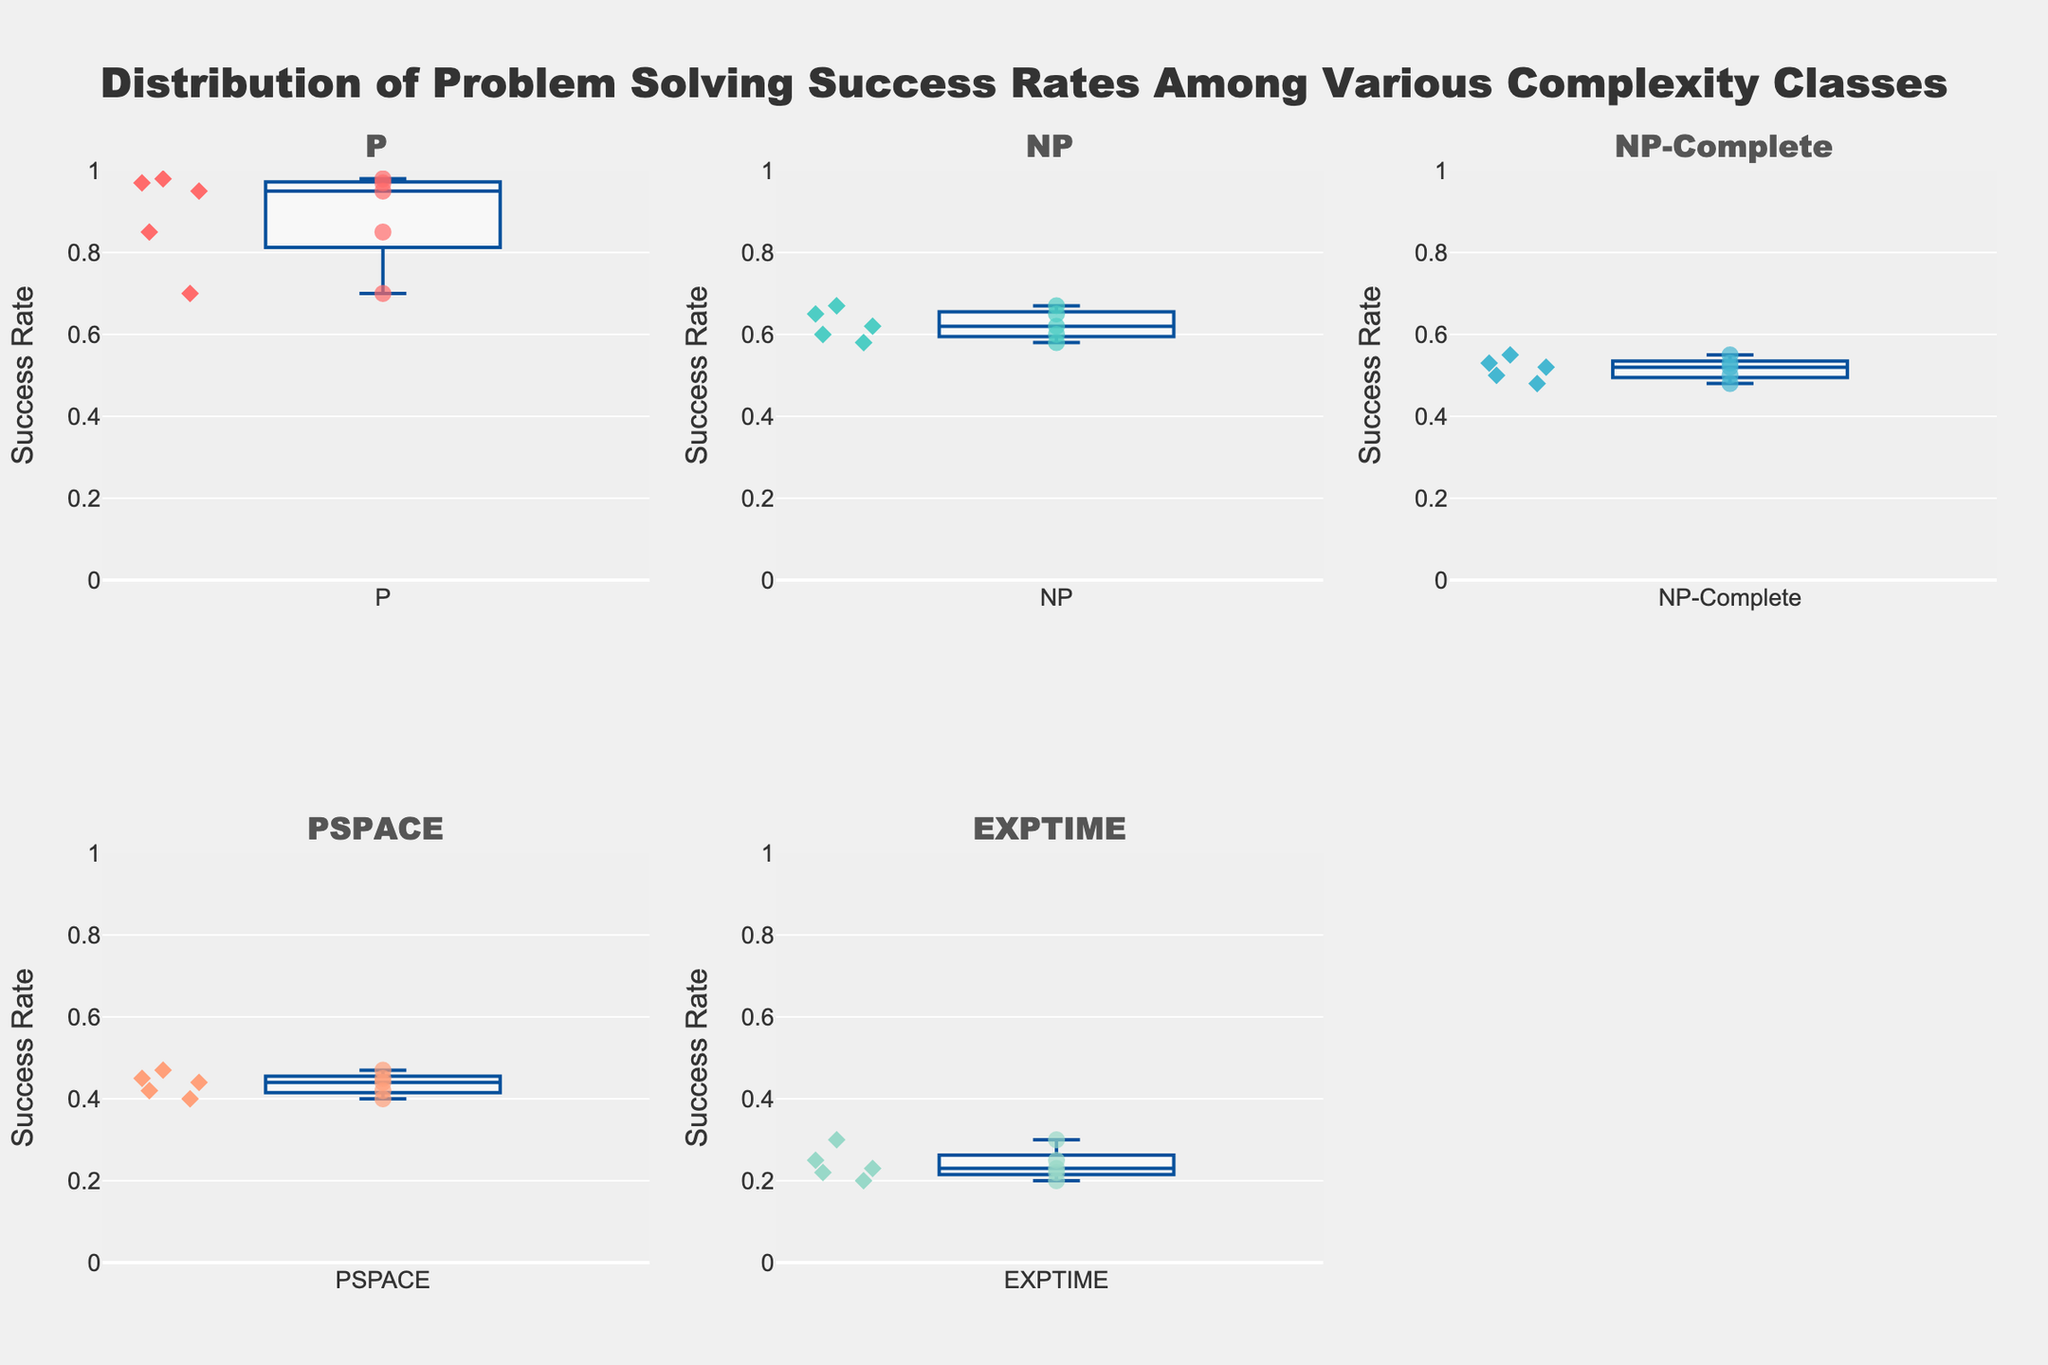Which complexity class has the highest average success rate? To find the highest average success rate, calculate the average success rates for each complexity class and compare them. The averages are: P (0.89), NP (0.624), NP-Complete (0.516), PSPACE (0.436), EXPTIME (0.24). Therefore, P has the highest average success rate.
Answer: P What is the median success rate for the NP-Complete class? To find the median, list the success rates for NP-Complete (0.55, 0.50, 0.52, 0.48, 0.53) in order (0.48, 0.50, 0.52, 0.53, 0.55) and find the middle value. The median success rate is 0.52.
Answer: 0.52 Which algorithm has the highest individual success rate? Look at the individual data points across all complexity classes. QuickSort in the P complexity class has the highest success rate at 0.98.
Answer: QuickSort Which complexity class shows the smallest range in success rates? Calculate the range for each class (max rate - min rate). P: 0.98-0.70 = 0.28, NP: 0.67-0.58 = 0.09, NP-Complete: 0.55-0.48 = 0.07, PSPACE: 0.47-0.40 = 0.07, EXPTIME: 0.30-0.20 = 0.10. The smallest range is found in NP-Complete and PSPACE, both at 0.07.
Answer: NP-Complete and PSPACE Compare the upper quartile (75th percentile) of P and NP complexity classes. Which one is higher? The upper quartile is the 75th percentile. For P, the success rates are (0.70, 0.85, 0.95, 0.97, 0.98). The 75th percentile is between 0.95 and 0.97. For NP, the success rates are (0.58, 0.60, 0.62, 0.65, 0.67). The 75th percentile is between 0.65 and 0.67. Thus, the upper quartile of P (between 0.95 and 0.97) is higher than that of NP (between 0.65 and 0.67).
Answer: P How do the success rates in the EXPTIME class compare with those in the PSPACE class? Compare the average success rates of EXPTIME (0.30, 0.20, 0.25, 0.22, 0.23) and PSPACE (0.45, 0.40, 0.42, 0.47, 0.44). The average for EXPTIME is 0.24 and for PSPACE is 0.436. Therefore, the PSPACE class has higher success rates on average than the EXPTIME class.
Answer: PSPACE What is the difference between the maximum success rate in the P class and the minimum success rate in the EXPTIME class? The maximum success rate in the P class is 0.98 (QuickSort), and the minimum success rate in the EXPTIME class is 0.20 (Chess). The difference is 0.98 - 0.20 = 0.78.
Answer: 0.78 Which complexity class has the most variation in success rates? Variation can be assessed using the range (max - min). For P: 0.28, NP: 0.09, NP-Complete: 0.07, PSPACE: 0.07, EXPTIME: 0.10. P has the highest variation with a range of 0.28.
Answer: P 